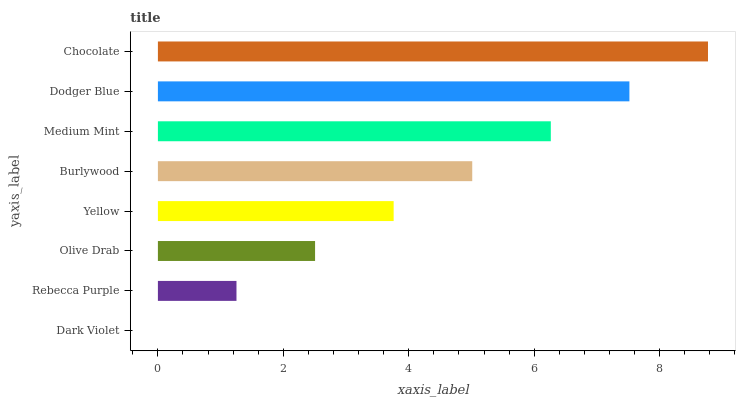Is Dark Violet the minimum?
Answer yes or no. Yes. Is Chocolate the maximum?
Answer yes or no. Yes. Is Rebecca Purple the minimum?
Answer yes or no. No. Is Rebecca Purple the maximum?
Answer yes or no. No. Is Rebecca Purple greater than Dark Violet?
Answer yes or no. Yes. Is Dark Violet less than Rebecca Purple?
Answer yes or no. Yes. Is Dark Violet greater than Rebecca Purple?
Answer yes or no. No. Is Rebecca Purple less than Dark Violet?
Answer yes or no. No. Is Burlywood the high median?
Answer yes or no. Yes. Is Yellow the low median?
Answer yes or no. Yes. Is Rebecca Purple the high median?
Answer yes or no. No. Is Chocolate the low median?
Answer yes or no. No. 